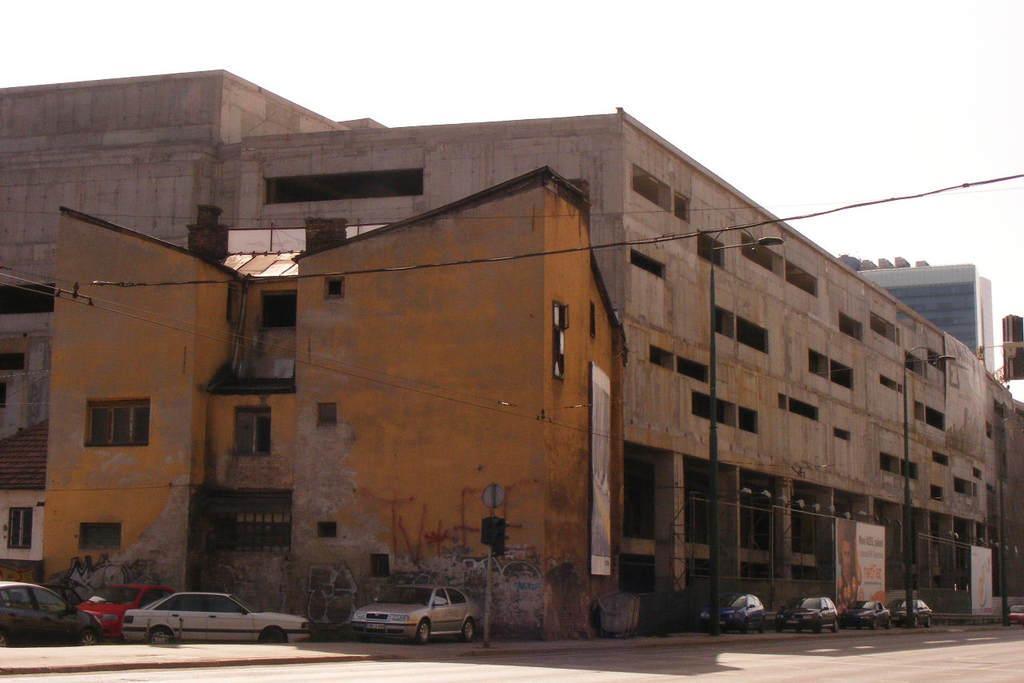How would you summarize this image in a sentence or two? In the center of the image there are buildings. There are windows. At the bottom of the image there is road. There are cars. There are street lights. At the top of the image there is sky. 